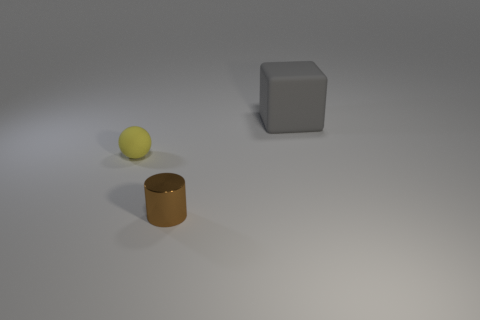Do the small brown thing and the tiny object left of the metallic cylinder have the same shape?
Your answer should be very brief. No. What number of things are matte objects in front of the large gray rubber object or objects that are to the right of the matte sphere?
Keep it short and to the point. 3. What is the material of the yellow thing?
Make the answer very short. Rubber. What number of other objects are the same size as the yellow object?
Your response must be concise. 1. What size is the rubber object that is right of the brown cylinder?
Provide a succinct answer. Large. There is a small object that is behind the tiny thing on the right side of the rubber thing left of the gray object; what is its material?
Give a very brief answer. Rubber. Do the small brown metal object and the big rubber object have the same shape?
Offer a terse response. No. What number of matte things are tiny purple cylinders or cylinders?
Offer a very short reply. 0. How many purple metallic balls are there?
Give a very brief answer. 0. What color is the matte sphere that is the same size as the cylinder?
Your response must be concise. Yellow. 